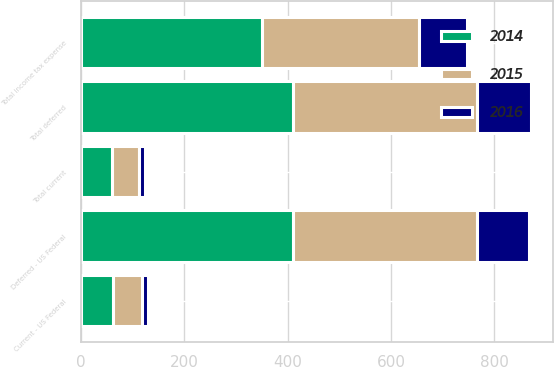Convert chart. <chart><loc_0><loc_0><loc_500><loc_500><stacked_bar_chart><ecel><fcel>Current - US Federal<fcel>Total current<fcel>Deferred - US Federal<fcel>Total deferred<fcel>Total income tax expense<nl><fcel>2016<fcel>12<fcel>12<fcel>101<fcel>104<fcel>92<nl><fcel>2015<fcel>55<fcel>52<fcel>357<fcel>357<fcel>305<nl><fcel>2014<fcel>62<fcel>60<fcel>410<fcel>410<fcel>350<nl></chart> 